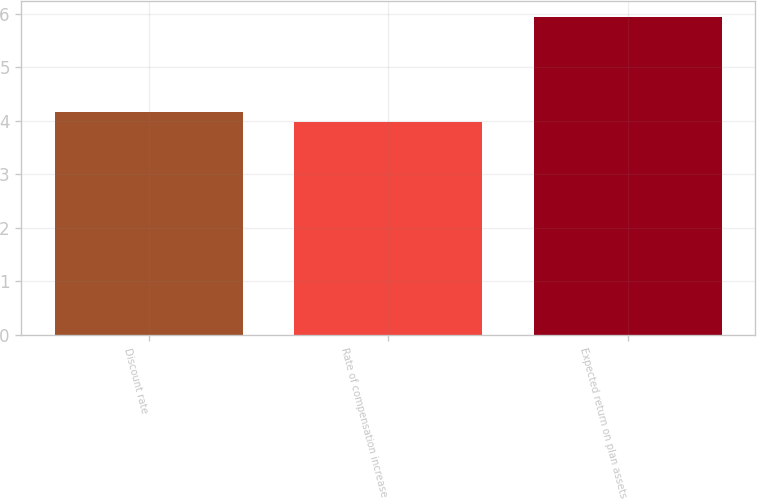Convert chart. <chart><loc_0><loc_0><loc_500><loc_500><bar_chart><fcel>Discount rate<fcel>Rate of compensation increase<fcel>Expected return on plan assets<nl><fcel>4.17<fcel>3.97<fcel>5.94<nl></chart> 